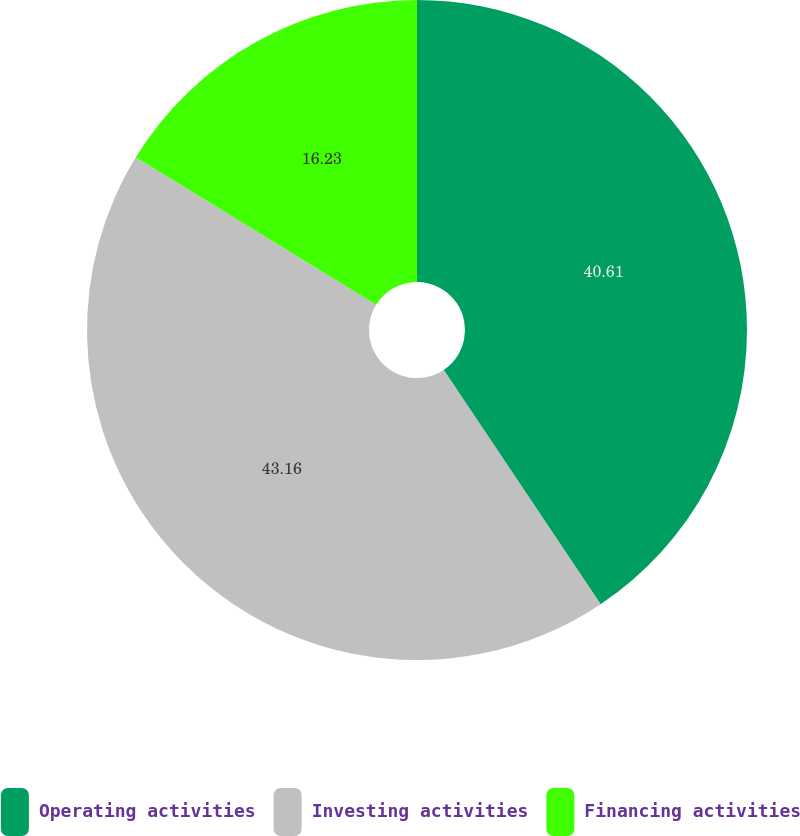Convert chart to OTSL. <chart><loc_0><loc_0><loc_500><loc_500><pie_chart><fcel>Operating activities<fcel>Investing activities<fcel>Financing activities<nl><fcel>40.61%<fcel>43.16%<fcel>16.23%<nl></chart> 